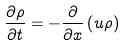Convert formula to latex. <formula><loc_0><loc_0><loc_500><loc_500>\frac { \partial \rho } { \partial t } = - \frac { \partial } { \partial x } \left ( u \rho \right )</formula> 